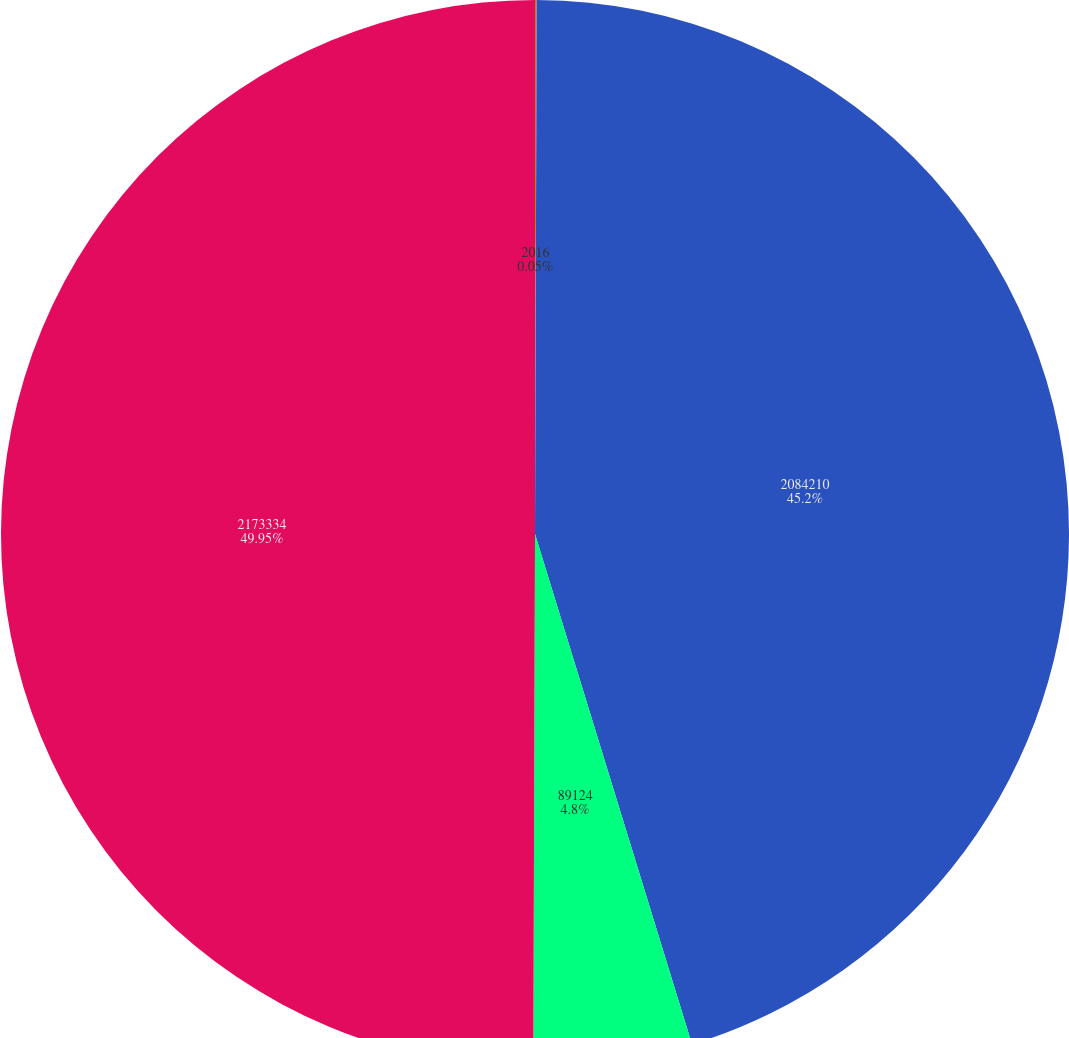Convert chart to OTSL. <chart><loc_0><loc_0><loc_500><loc_500><pie_chart><fcel>2016<fcel>2084210<fcel>89124<fcel>2173334<nl><fcel>0.05%<fcel>45.2%<fcel>4.8%<fcel>49.95%<nl></chart> 